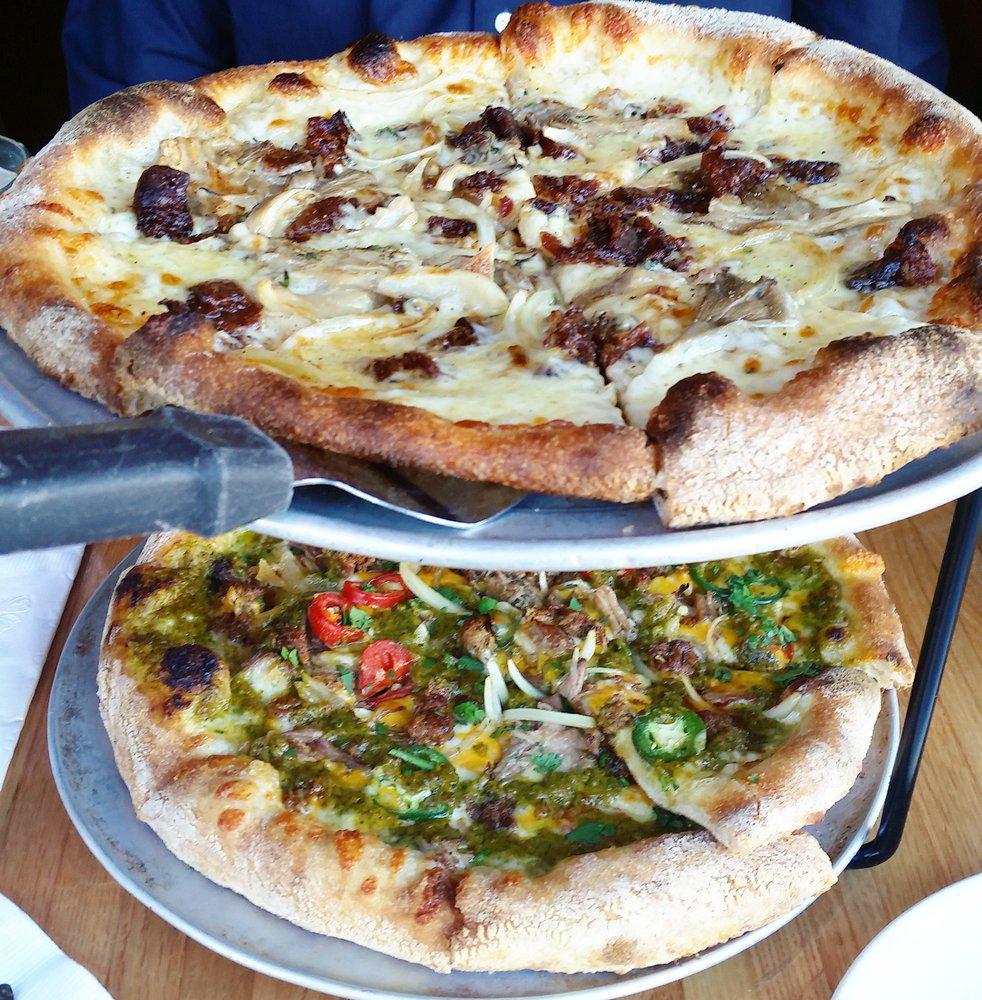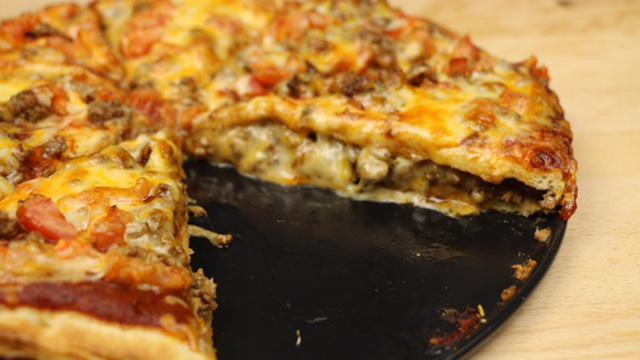The first image is the image on the left, the second image is the image on the right. Assess this claim about the two images: "The right image shows one slice missing from a stuffed pizza, and the left image features at least one sliced pizza with no slices missing.". Correct or not? Answer yes or no. Yes. 